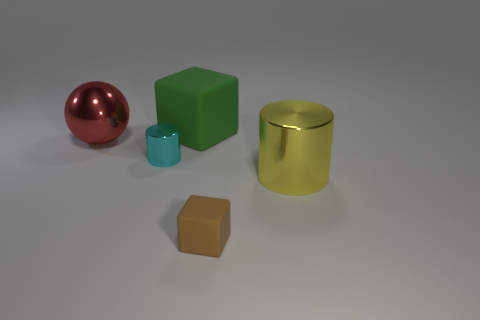There is a large cube to the left of the metallic cylinder that is on the right side of the small cyan metallic thing; is there a tiny object that is left of it?
Offer a terse response. Yes. What size is the metallic thing that is both right of the sphere and to the left of the tiny brown block?
Ensure brevity in your answer.  Small. How many large green things are made of the same material as the cyan thing?
Make the answer very short. 0. What number of spheres are tiny green metal objects or big red shiny objects?
Keep it short and to the point. 1. How big is the cube to the right of the rubber block behind the metallic cylinder in front of the cyan cylinder?
Your answer should be compact. Small. What is the color of the metallic thing that is both in front of the big red metal thing and behind the yellow cylinder?
Your answer should be very brief. Cyan. Does the brown matte block have the same size as the shiny cylinder to the left of the yellow thing?
Offer a very short reply. Yes. Are there any other things that have the same shape as the large red metal object?
Ensure brevity in your answer.  No. There is a tiny rubber thing that is the same shape as the big green rubber object; what color is it?
Your answer should be compact. Brown. Do the sphere and the brown rubber cube have the same size?
Offer a terse response. No. 